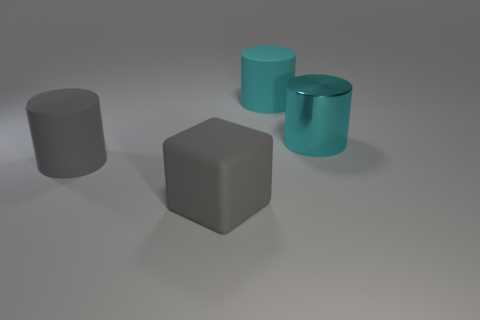Add 2 big metal cylinders. How many objects exist? 6 Subtract all cubes. How many objects are left? 3 Subtract 0 brown cylinders. How many objects are left? 4 Subtract all green balls. Subtract all gray objects. How many objects are left? 2 Add 4 gray blocks. How many gray blocks are left? 5 Add 2 big metallic objects. How many big metallic objects exist? 3 